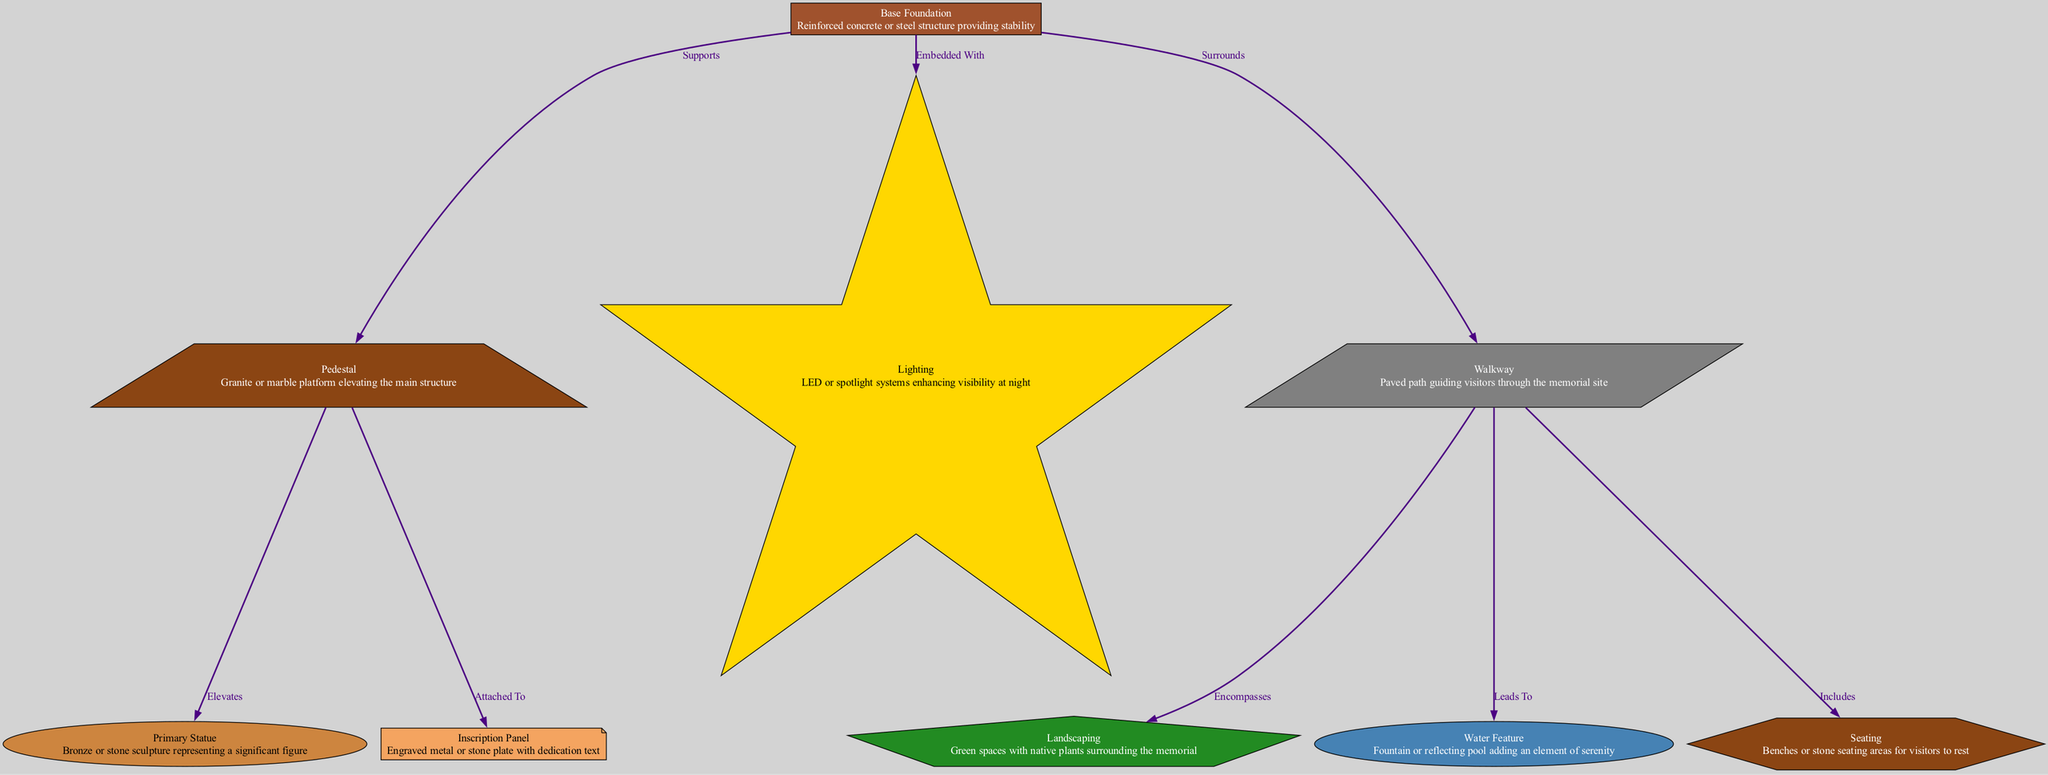What is the material used for the base foundation? The diagram specifies that the base foundation is made of reinforced concrete or steel, based on the description provided next to the node labeled "Base Foundation."
Answer: Reinforced concrete or steel How many nodes are present in the diagram? By counting each unique node listed, there are a total of eight nodes in the diagram: base foundation, pedestal, primary statue, inscription panel, landscaping, lighting, walkway, water feature, and seating.
Answer: 8 Which element elevates the primary statue? The relationship in the diagram indicates that the pedestal elevates the primary statue, as shown by the edge that connects the pedestal to the primary statue with the label "Elevates."
Answer: Pedestal What surrounds the base foundation? According to the edges in the diagram, the walkway surrounds the base foundation, as indicated by the connection line that shows the base foundation as the source and the walkway as the target labeled "Surrounds."
Answer: Walkway Which element adds serenity to the memorial? The diagram states that the water feature is a fountain or reflecting pool that adds an element of serenity to the memorial, as described in the node for "Water Feature."
Answer: Water Feature What is the function of the inscription panel? The inscription panel is described as an engraved metal or stone plate with dedication text, and it is connected to the pedestal, indicating its function is to convey dedication information.
Answer: Dedication text How does the walkway relate to landscaping? The relationship in the diagram shows that the walkway encompasses the landscaping based on the edge labeled "Encompasses," indicating that the walkway is around the landscaping area.
Answer: Encompasses What is embedded within the base foundation? The diagram describes that lighting is embedded within the base foundation, as indicated by the edge that connects these two elements with the label "Embedded With."
Answer: Lighting 